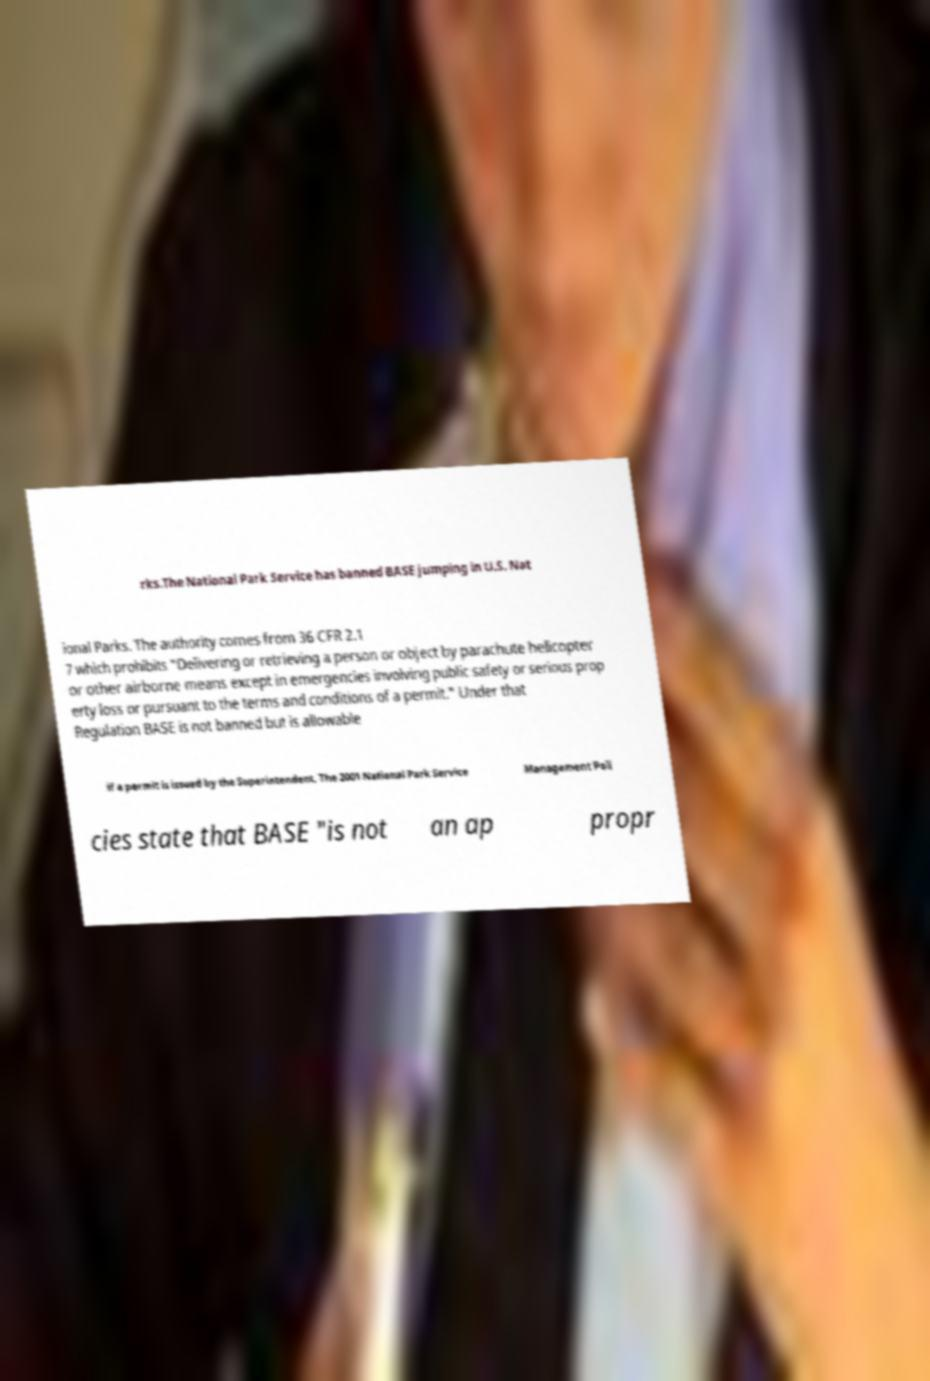Could you extract and type out the text from this image? rks.The National Park Service has banned BASE jumping in U.S. Nat ional Parks. The authority comes from 36 CFR 2.1 7 which prohibits "Delivering or retrieving a person or object by parachute helicopter or other airborne means except in emergencies involving public safety or serious prop erty loss or pursuant to the terms and conditions of a permit." Under that Regulation BASE is not banned but is allowable if a permit is issued by the Superintendent. The 2001 National Park Service Management Poli cies state that BASE "is not an ap propr 